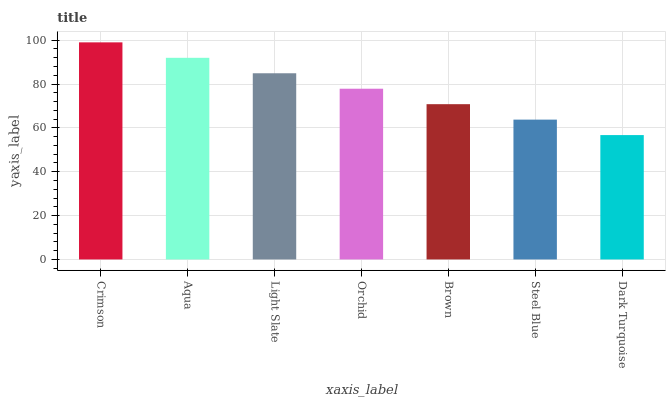Is Dark Turquoise the minimum?
Answer yes or no. Yes. Is Crimson the maximum?
Answer yes or no. Yes. Is Aqua the minimum?
Answer yes or no. No. Is Aqua the maximum?
Answer yes or no. No. Is Crimson greater than Aqua?
Answer yes or no. Yes. Is Aqua less than Crimson?
Answer yes or no. Yes. Is Aqua greater than Crimson?
Answer yes or no. No. Is Crimson less than Aqua?
Answer yes or no. No. Is Orchid the high median?
Answer yes or no. Yes. Is Orchid the low median?
Answer yes or no. Yes. Is Steel Blue the high median?
Answer yes or no. No. Is Brown the low median?
Answer yes or no. No. 